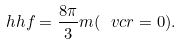<formula> <loc_0><loc_0><loc_500><loc_500>\ h h f = \frac { 8 \pi } { 3 } m ( \ v c { r } = 0 ) .</formula> 